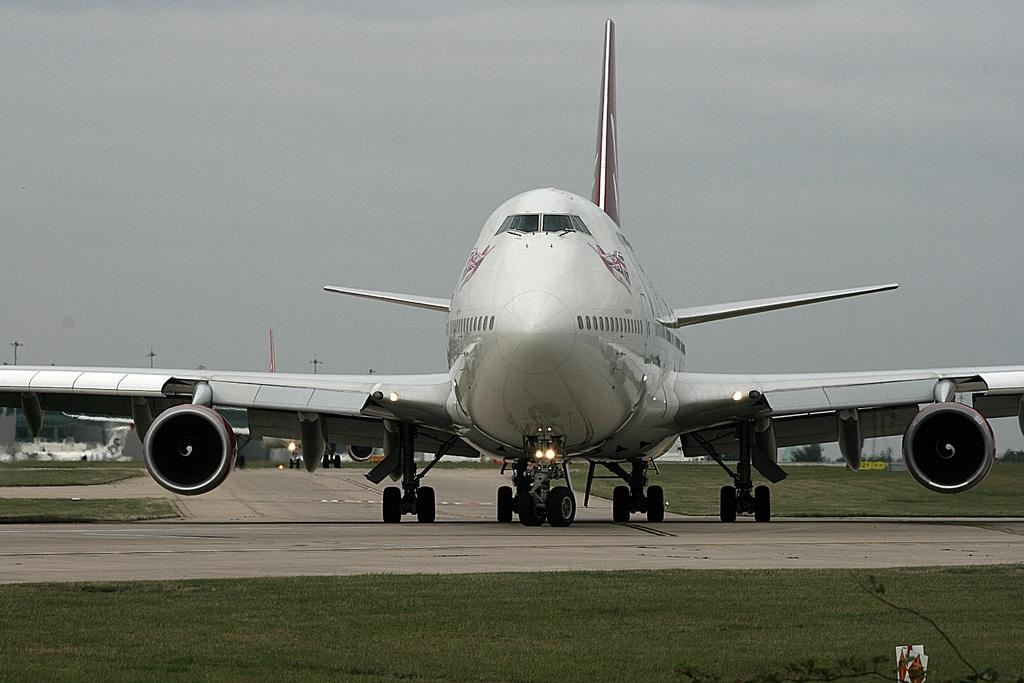What is the main subject of the image? The main subject of the image is aeroplanes. Can you describe the activity of one of the aeroplanes in the image? One aeroplane is moving on the runway. What type of terrain is visible in the image? There is grass visible on the ground. What type of bells can be heard ringing in the image? There are no bells present in the image, and therefore no sounds can be heard. 